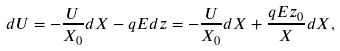<formula> <loc_0><loc_0><loc_500><loc_500>d U = - \frac { U } { X _ { 0 } } d X - q E d z = - \frac { U } { X _ { 0 } } d X + \frac { q E z _ { 0 } } { X } d X ,</formula> 